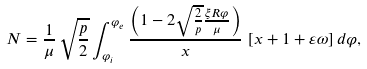<formula> <loc_0><loc_0><loc_500><loc_500>N = \frac { 1 } { \mu } \, \sqrt { \frac { p } { 2 } } \int _ { \varphi _ { i } } ^ { \varphi _ { e } } \frac { \left ( 1 - 2 \sqrt { \frac { 2 } { p } } \frac { \xi R \varphi } { \mu } \right ) } { x } \, \left [ x + 1 + \varepsilon \omega \right ] d \varphi ,</formula> 